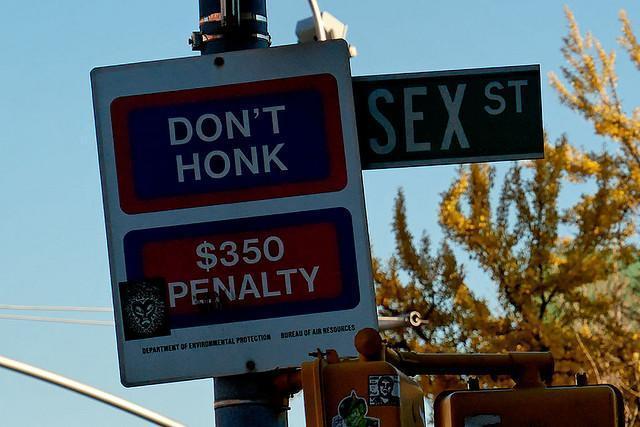How many stickers are on the sign?
Give a very brief answer. 1. How many traffic lights are there?
Give a very brief answer. 2. How many people are in the picture?
Give a very brief answer. 0. 